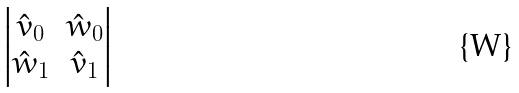Convert formula to latex. <formula><loc_0><loc_0><loc_500><loc_500>\begin{vmatrix} \hat { v } _ { 0 } & \hat { w } _ { 0 } \\ \hat { w } _ { 1 } & \hat { v } _ { 1 } \end{vmatrix}</formula> 